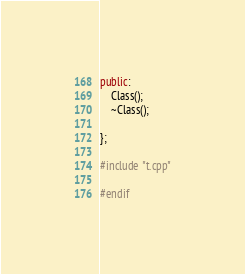Convert code to text. <code><loc_0><loc_0><loc_500><loc_500><_C++_>public:
    Class();
    ~Class();

};

#include "t.cpp"

#endif</code> 